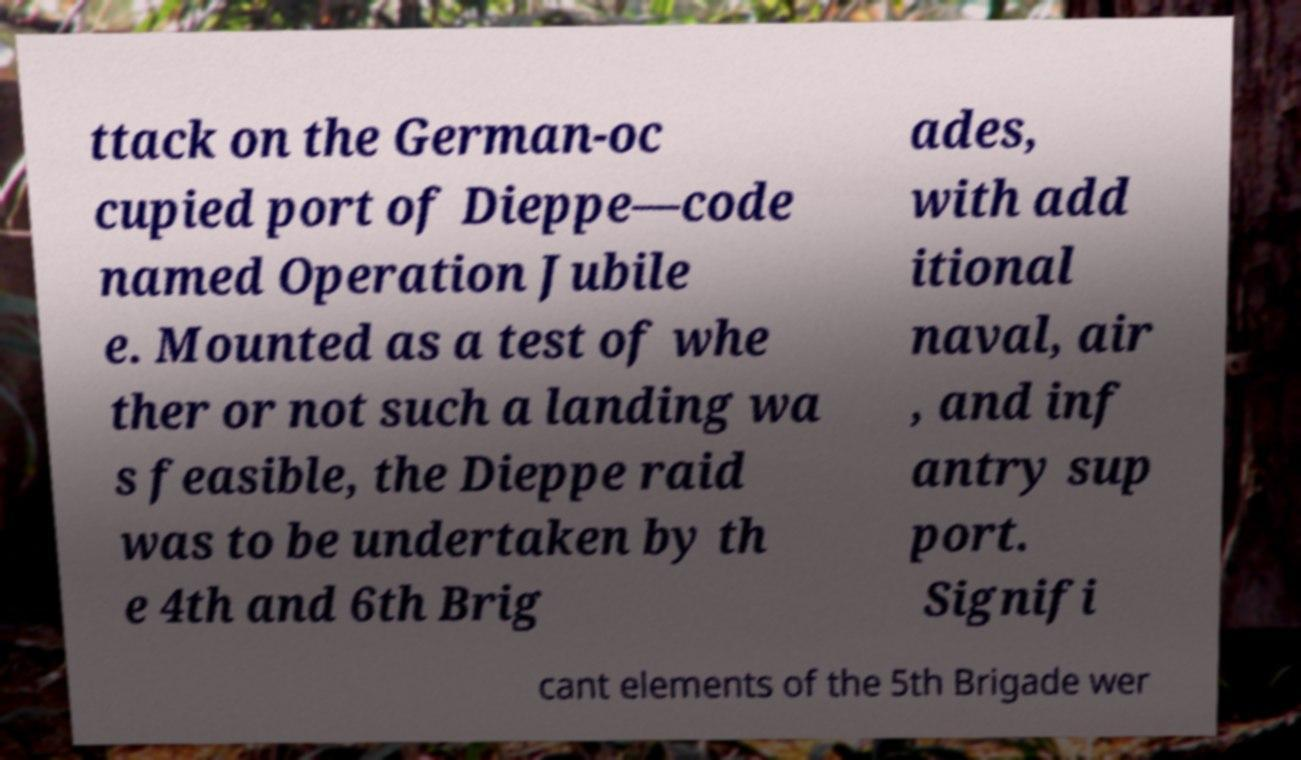Can you accurately transcribe the text from the provided image for me? ttack on the German-oc cupied port of Dieppe—code named Operation Jubile e. Mounted as a test of whe ther or not such a landing wa s feasible, the Dieppe raid was to be undertaken by th e 4th and 6th Brig ades, with add itional naval, air , and inf antry sup port. Signifi cant elements of the 5th Brigade wer 